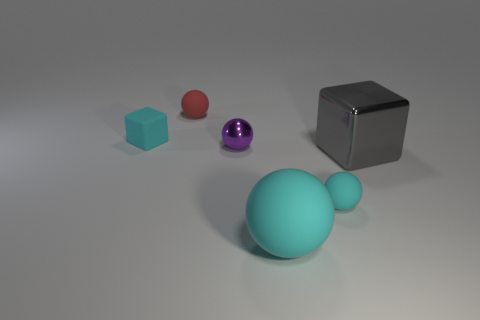How many other objects are the same shape as the large cyan rubber object?
Offer a terse response. 3. Are the cyan cube and the cube to the right of the tiny red rubber ball made of the same material?
Your answer should be compact. No. What is the size of the sphere that is the same material as the gray thing?
Your response must be concise. Small. There is a shiny thing behind the large gray block; how big is it?
Your response must be concise. Small. What number of other purple metal spheres have the same size as the purple sphere?
Keep it short and to the point. 0. There is another matte sphere that is the same color as the big sphere; what is its size?
Ensure brevity in your answer.  Small. Is there a object of the same color as the tiny block?
Offer a terse response. Yes. There is a sphere that is the same size as the gray cube; what color is it?
Provide a short and direct response. Cyan. Is the color of the big matte thing the same as the tiny block that is behind the small cyan sphere?
Your answer should be very brief. Yes. What is the color of the big shiny block?
Your answer should be compact. Gray. 